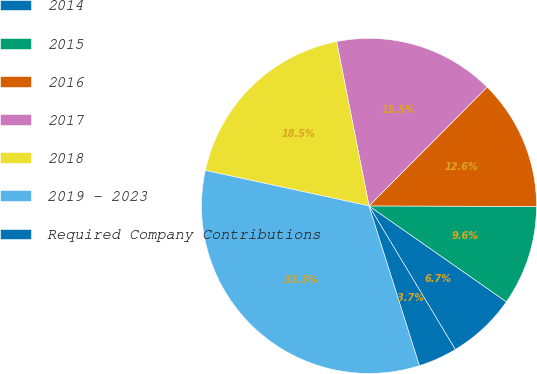Convert chart to OTSL. <chart><loc_0><loc_0><loc_500><loc_500><pie_chart><fcel>2014<fcel>2015<fcel>2016<fcel>2017<fcel>2018<fcel>2019 - 2023<fcel>Required Company Contributions<nl><fcel>6.69%<fcel>9.65%<fcel>12.6%<fcel>15.55%<fcel>18.5%<fcel>33.27%<fcel>3.74%<nl></chart> 